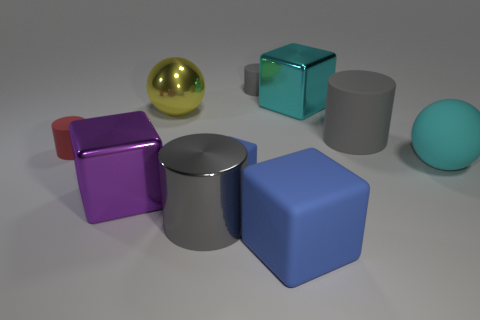The red object that is the same shape as the gray metal object is what size?
Make the answer very short. Small. What number of other things are there of the same material as the small red cylinder
Provide a succinct answer. 5. Are the tiny blue block and the blue cube that is in front of the small cube made of the same material?
Your response must be concise. Yes. Are there fewer large shiny things behind the big cyan matte sphere than large yellow spheres that are to the right of the yellow metallic thing?
Your answer should be compact. No. There is a cylinder left of the metal sphere; what is its color?
Your answer should be very brief. Red. What number of other objects are the same color as the small block?
Your answer should be very brief. 1. Does the block that is in front of the purple block have the same size as the large cyan rubber object?
Offer a very short reply. Yes. There is a small gray thing; how many large balls are to the right of it?
Your answer should be very brief. 1. Are there any red matte things of the same size as the yellow metal ball?
Your answer should be compact. No. Do the tiny cube and the big rubber ball have the same color?
Keep it short and to the point. No. 